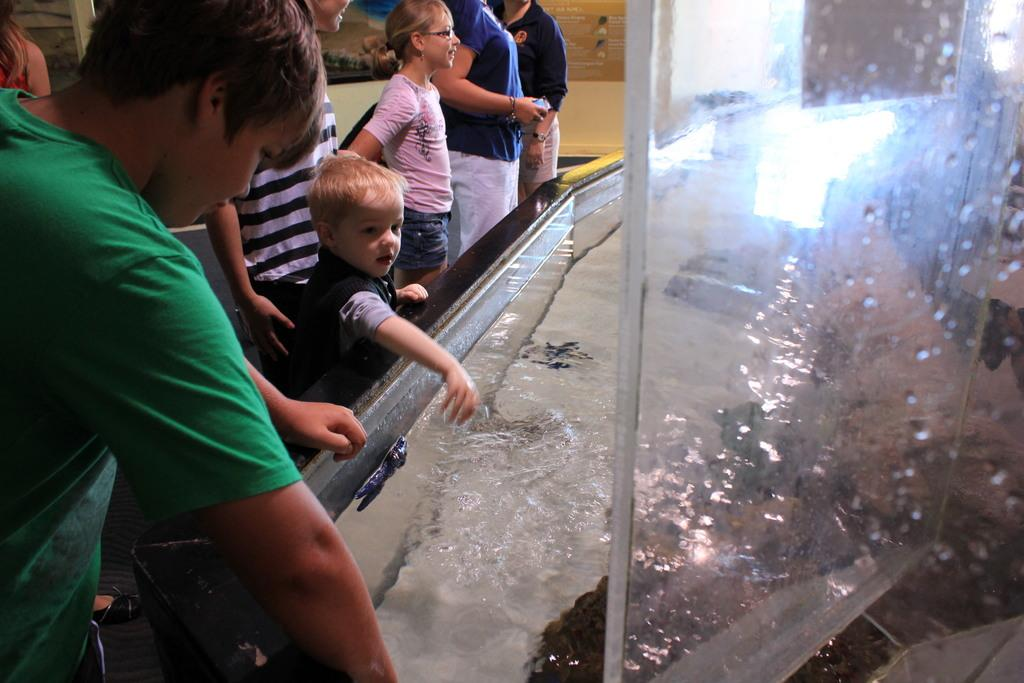How many people are in the image? There are persons in the image, but the exact number is not specified. What is the primary element visible in the image? Water is visible in the image. What object can be seen in the image that might be used for drinking? There is a glass in the image. What can be seen in the background of the image? There is a wall and posters in the background of the image. What type of soda is being poured into the glass in the image? There is no soda visible in the image; it only shows water and a glass. How many cats are sitting on the wall in the background of the image? There are no cats present in the image; it only features persons, water, a glass, a wall, and posters. 